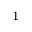Convert formula to latex. <formula><loc_0><loc_0><loc_500><loc_500>^ { 1 }</formula> 